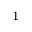Convert formula to latex. <formula><loc_0><loc_0><loc_500><loc_500>^ { 1 }</formula> 